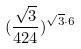<formula> <loc_0><loc_0><loc_500><loc_500>( \frac { \sqrt { 3 } } { 4 2 4 } ) ^ { \sqrt { 3 } \cdot 6 }</formula> 